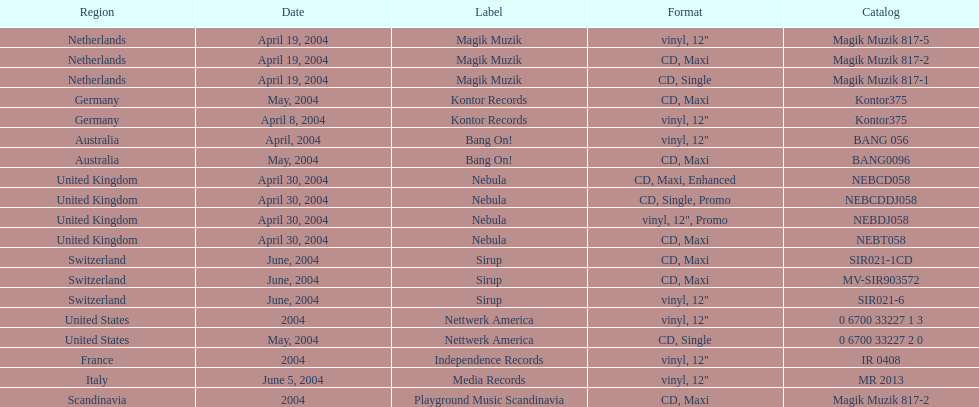Which format was utilized by france? Vinyl, 12". 